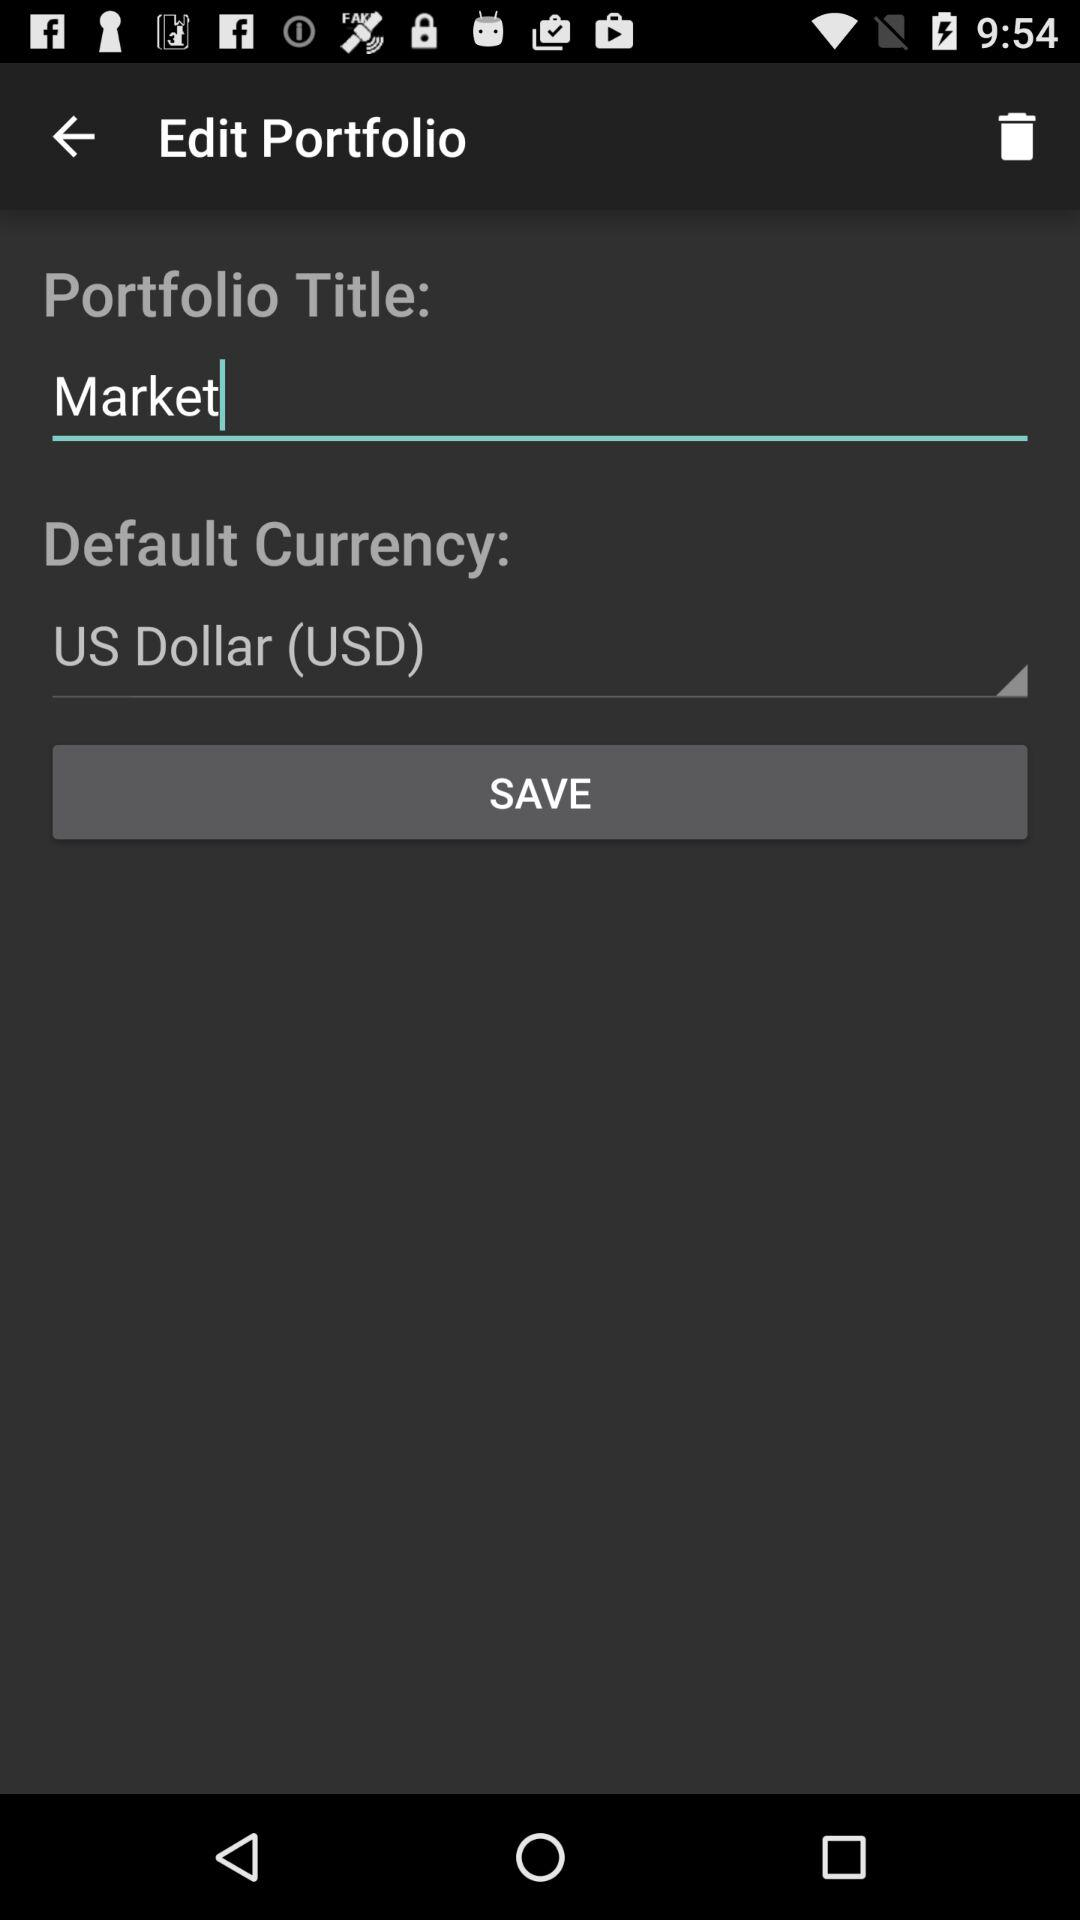What is the portfolio title? The portfolio title is Market. 